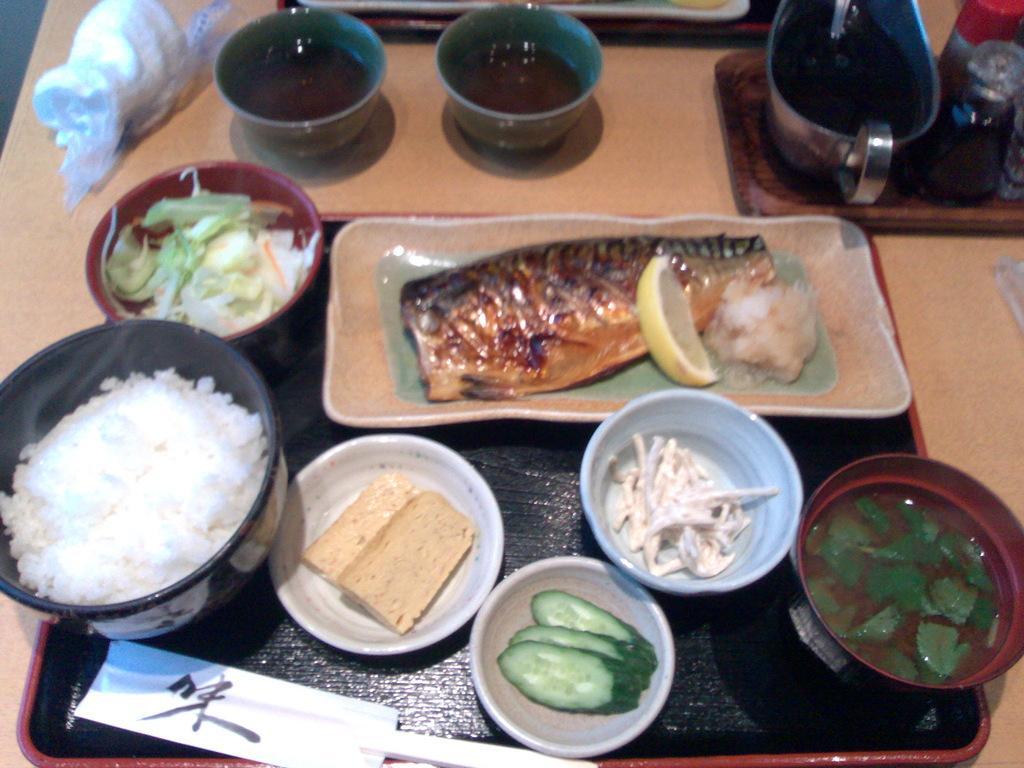Can you describe this image briefly? In this image we can see a table. On the table there are trays, bowls with some items. On the trays there are plates with food items, bowls with food item and some other things. 